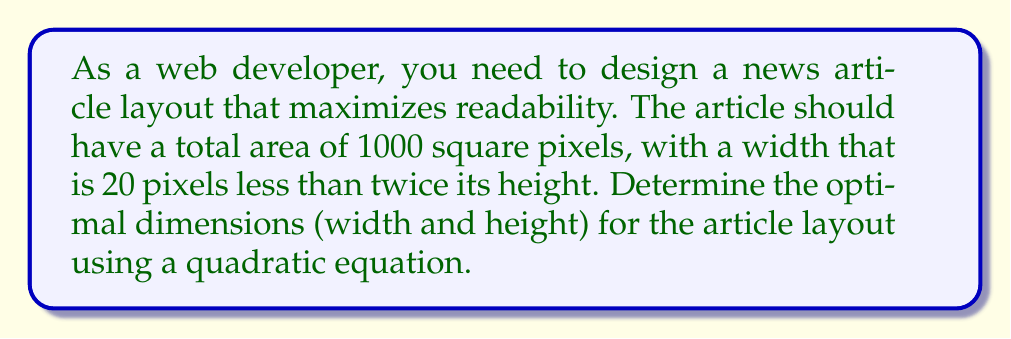Solve this math problem. Let's approach this step-by-step:

1) Let $h$ represent the height of the article in pixels.
   Let $w$ represent the width of the article in pixels.

2) Given information:
   - Area = 1000 square pixels
   - Width is 20 pixels less than twice the height

3) We can express these as equations:
   $$ w \cdot h = 1000 $$
   $$ w = 2h - 20 $$

4) Substitute the second equation into the first:
   $$ (2h - 20) \cdot h = 1000 $$

5) Expand the equation:
   $$ 2h^2 - 20h = 1000 $$

6) Rearrange to standard quadratic form:
   $$ 2h^2 - 20h - 1000 = 0 $$

7) Use the quadratic formula: $x = \frac{-b \pm \sqrt{b^2 - 4ac}}{2a}$
   Where $a = 2$, $b = -20$, and $c = -1000$

8) Solve:
   $$ h = \frac{20 \pm \sqrt{(-20)^2 - 4(2)(-1000)}}{2(2)} $$
   $$ h = \frac{20 \pm \sqrt{400 + 8000}}{4} $$
   $$ h = \frac{20 \pm \sqrt{8400}}{4} $$
   $$ h = \frac{20 \pm 91.65}{4} $$

9) This gives us two solutions:
   $h = 27.91$ or $h = -17.91$

10) Since height can't be negative, we use $h = 27.91$

11) Round to the nearest pixel: $h = 28$

12) Calculate width: $w = 2h - 20 = 2(28) - 20 = 36$

Therefore, the optimal dimensions are 36 pixels wide by 28 pixels high.
Answer: 36 pixels wide, 28 pixels high 